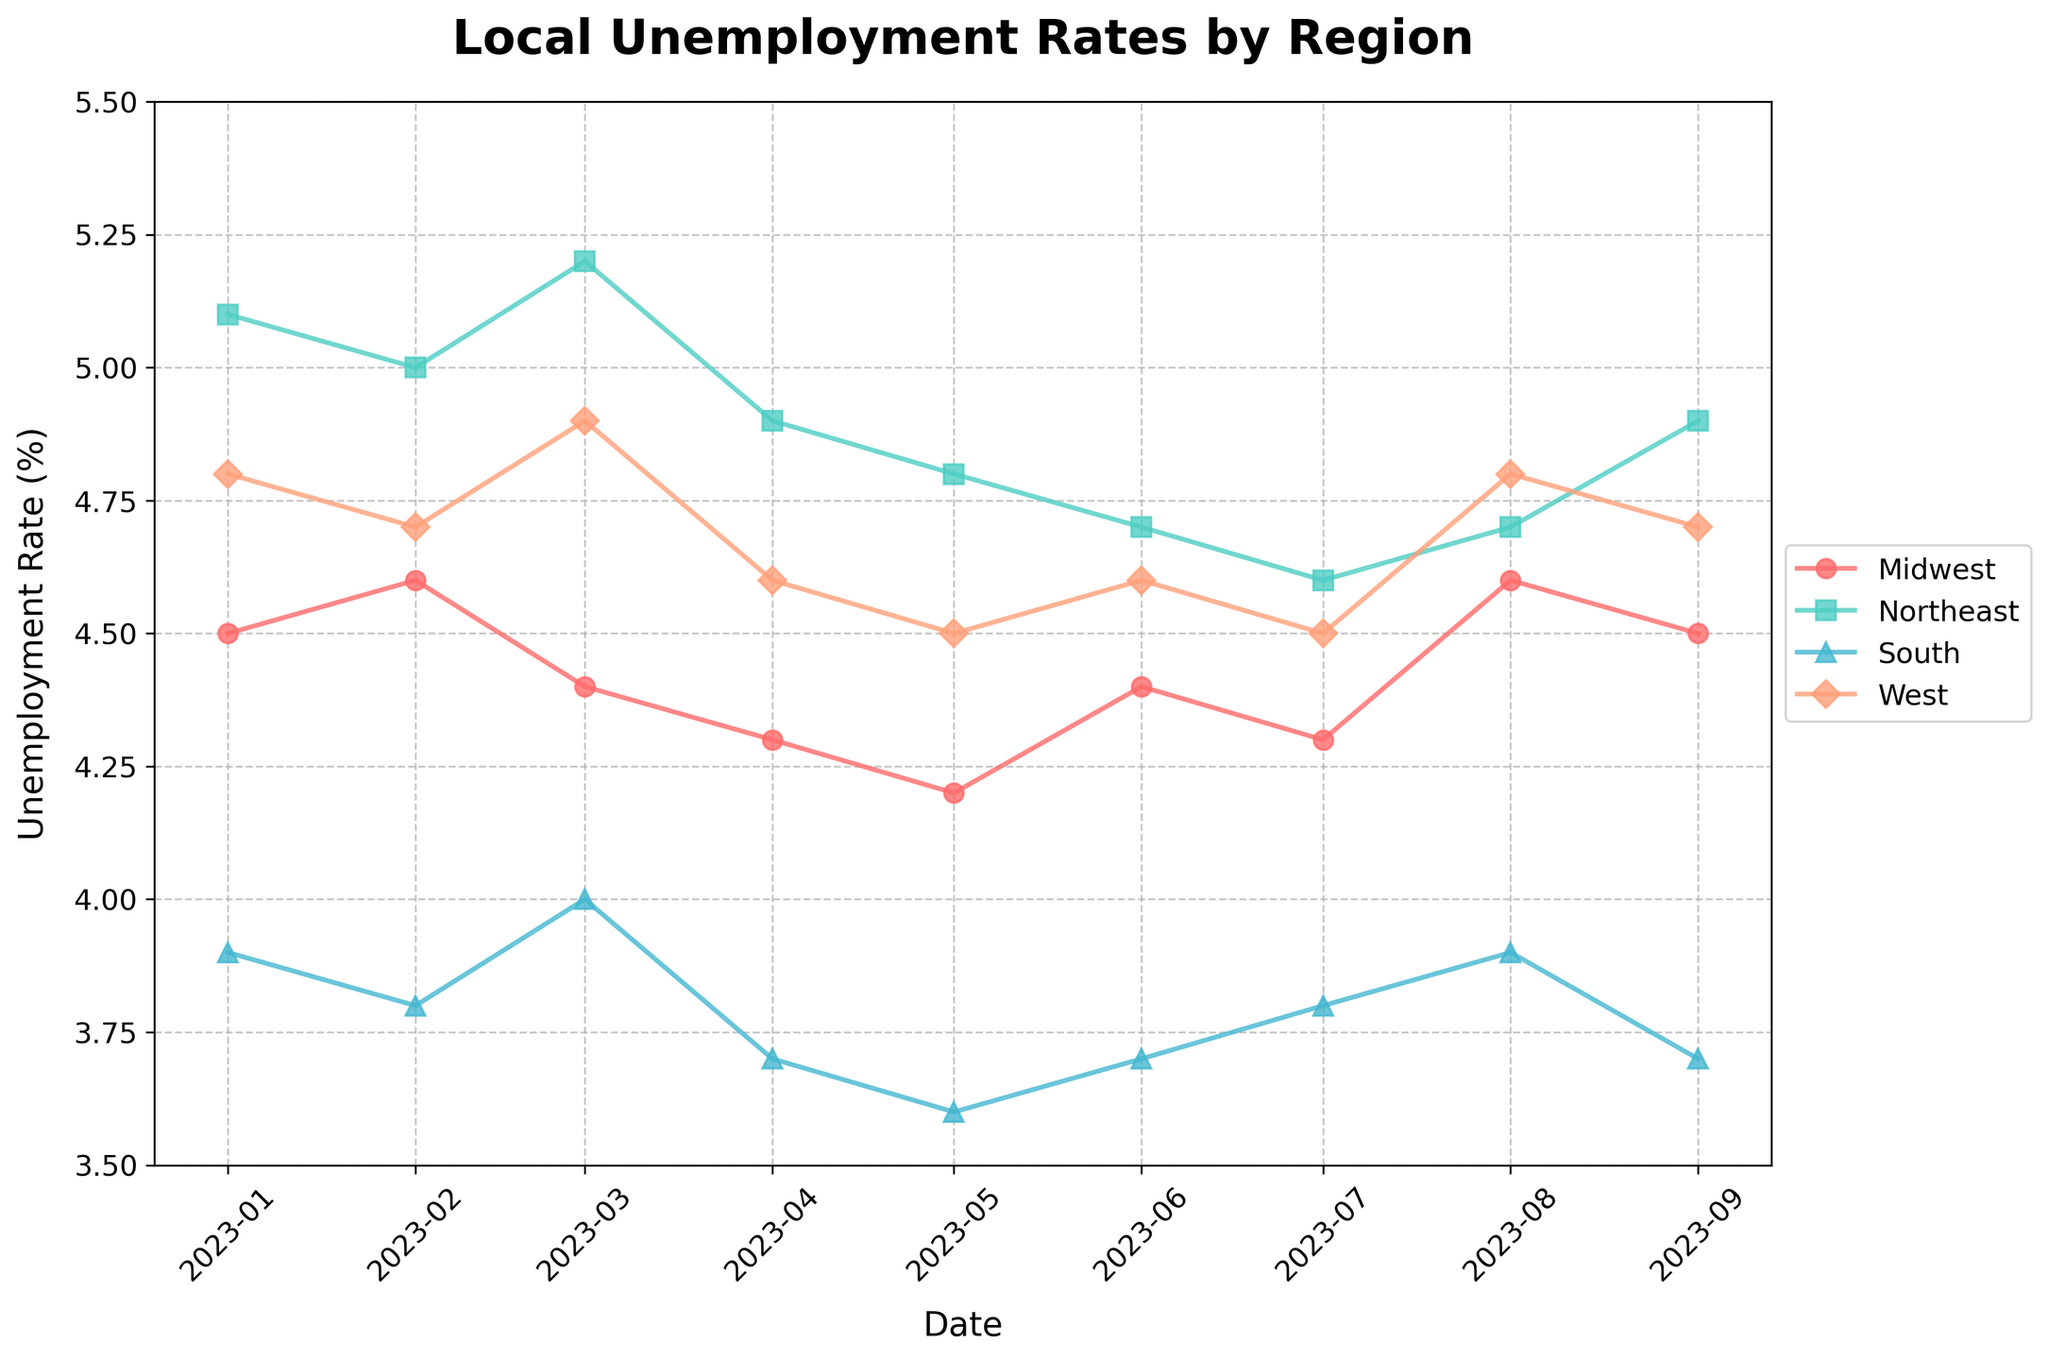What is the title of the plot? The title is displayed at the top center of the plot.
Answer: Local Unemployment Rates by Region Which region has the highest unemployment rate in January 2023? By observing the plot, check the unemployment rate data points for January 2023. The highest point is for the Northeast region.
Answer: Northeast How does the unemployment rate of the Midwest region change from January to September 2023? Follow the line for the Midwest from January to September 2023, noting the values at each marker. It starts at 4.5% in January and ends at 4.5% in September with some fluctuations.
Answer: It fluctuates but remains the same in January and September By how much did the unemployment rate in the South region change from April to May 2023? Find the markers for the South region in April and May. Subtract the April rate (3.7%) from the May rate (3.6%).
Answer: Decreased by 0.1% Which two regions have the most similar unemployment rates in August 2023? Look at the markers for August 2023. The Midwest and West regions both have an unemployment rate of 4.6%.
Answer: Midwest and West From which month to which month does the Northeast region show a decreasing trend in its unemployment rate? Trace the line for the Northeast region, identify periods where the line consistently goes down. From March (5.2%) to July (4.6%), there's a clear downward trend.
Answer: March to July What is the average unemployment rate for the West region shown on the graph? Add all unemployment rates for the West (4.8, 4.7, 4.9, 4.6, 4.5, 4.6, 4.5, 4.8, 4.7). Divide by the number of data points (9). (4.8+4.7+4.9+4.6+4.5+4.6+4.5+4.8+4.7)/9 = 4.7
Answer: 4.7 Which month shows the highest disparity in unemployment rates among all regions? Compare the difference between the highest and lowest rates each month. March has rates from 3.7% (South) to 5.2% (Northeast), the widest gap.
Answer: March How does the trend in unemployment rate for the NASDAQ (South region) compare to the Russell 2000 (West region)? Observe both lines. South consistently shows lower rates, and a more steady decrease with minor fluctuations, while West fluctuates more but generally remains higher.
Answer: South shows a more steady and lower rate What is the overall trend of unemployment rates in the Northeast region from January to September 2023? Trace the line for the Northeast region; overall, it shows a decrease from 5.1% in January to 4.9% in September, with minor fluctuations.
Answer: Decreasing trend 